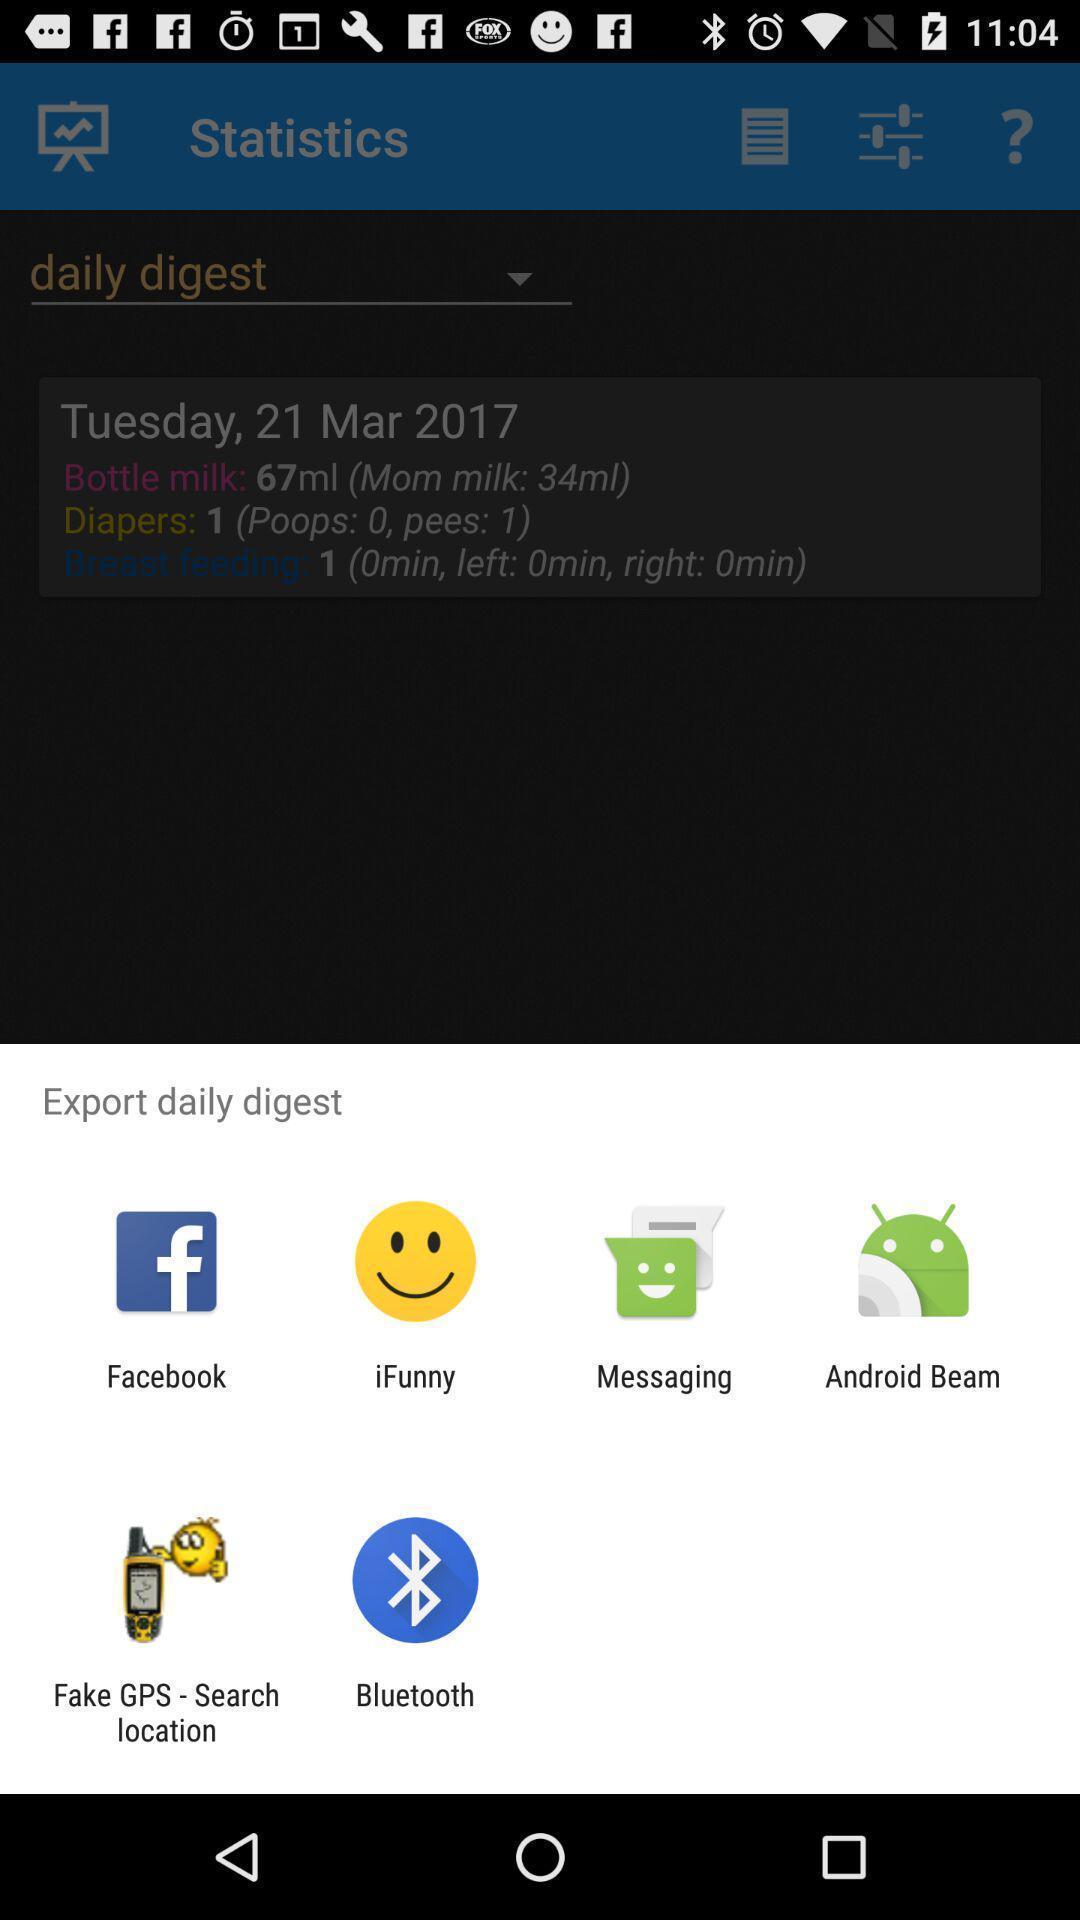What is the overall content of this screenshot? Pop-up showing different kinds of options to select. 